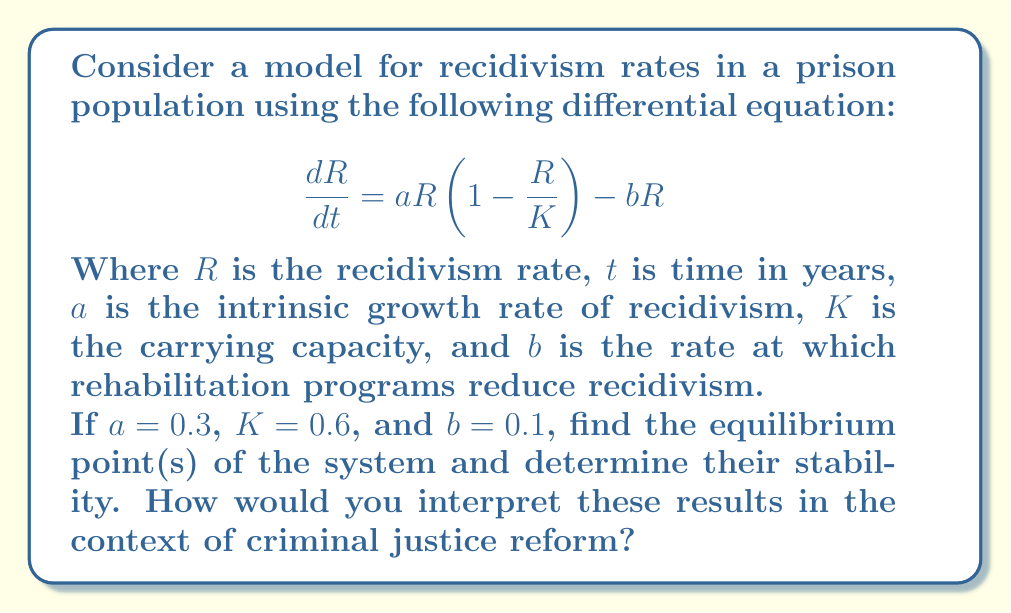Can you answer this question? 1) To find the equilibrium points, we set $\frac{dR}{dt} = 0$:

   $$0 = aR(1-\frac{R}{K}) - bR$$

2) Factor out R:

   $$0 = R(a(1-\frac{R}{K}) - b)$$

3) Solve for R:
   
   Either $R = 0$, or $a(1-\frac{R}{K}) - b = 0$

4) For the non-zero equilibrium:

   $$a(1-\frac{R}{K}) - b = 0$$
   $$a - \frac{aR}{K} = b$$
   $$a - b = \frac{aR}{K}$$
   $$R = \frac{K(a-b)}{a}$$

5) Substitute the given values:

   $$R = \frac{0.6(0.3-0.1)}{0.3} = 0.4$$

6) To determine stability, we evaluate the derivative of $\frac{dR}{dt}$ with respect to $R$ at each equilibrium point:

   $$\frac{d}{dR}(\frac{dR}{dt}) = a(1-\frac{2R}{K}) - b$$

7) At $R = 0$:
   
   $$\frac{d}{dR}(\frac{dR}{dt}) = 0.3 - 0.1 = 0.2 > 0$$
   
   This is unstable.

8) At $R = 0.4$:

   $$\frac{d}{dR}(\frac{dR}{dt}) = 0.3(1-\frac{2(0.4)}{0.6}) - 0.1 = -0.1 < 0$$
   
   This is stable.

Interpretation: The model predicts two equilibrium points: 0% recidivism (unstable) and 40% recidivism (stable). The stability of the 40% point suggests that, under current conditions, recidivism rates tend to gravitate towards this level. For criminal justice reform, this indicates that more aggressive intervention strategies might be needed to push the system towards a lower, stable equilibrium.
Answer: Equilibrium points: $R = 0$ (unstable) and $R = 0.4$ (stable) 